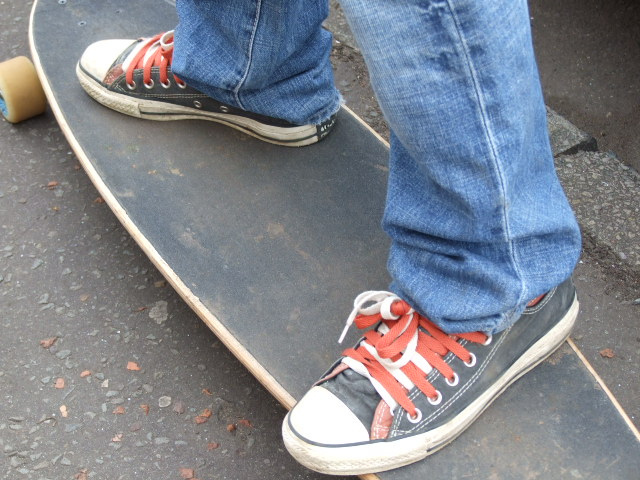What company created the shoes the person is wearing?
Answer the question using a single word or phrase. Converse 